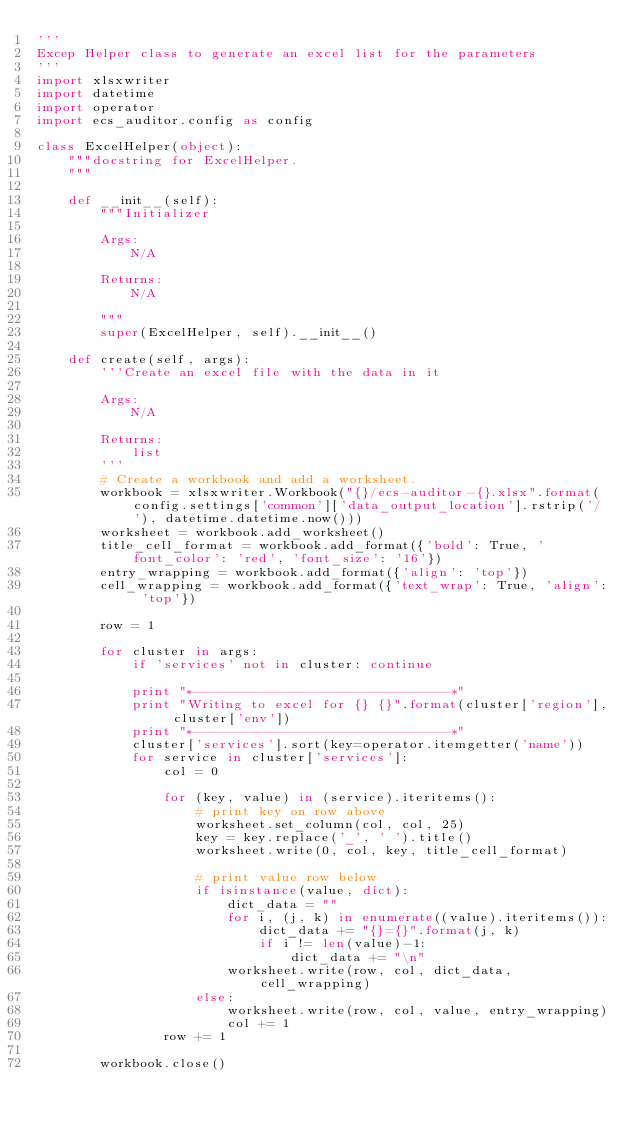Convert code to text. <code><loc_0><loc_0><loc_500><loc_500><_Python_>'''
Excep Helper class to generate an excel list for the parameters
'''
import xlsxwriter
import datetime
import operator
import ecs_auditor.config as config

class ExcelHelper(object):
    """docstring for ExcelHelper.
    """

    def __init__(self):
        """Initializer

        Args:
            N/A

        Returns:
            N/A

        """
        super(ExcelHelper, self).__init__()

    def create(self, args):
        '''Create an excel file with the data in it

        Args:
            N/A

        Returns:
            list
        '''
        # Create a workbook and add a worksheet.
        workbook = xlsxwriter.Workbook("{}/ecs-auditor-{}.xlsx".format(config.settings['common']['data_output_location'].rstrip('/'), datetime.datetime.now()))
        worksheet = workbook.add_worksheet()
        title_cell_format = workbook.add_format({'bold': True, 'font_color': 'red', 'font_size': '16'})
        entry_wrapping = workbook.add_format({'align': 'top'})
        cell_wrapping = workbook.add_format({'text_wrap': True, 'align': 'top'})

        row = 1

        for cluster in args:
            if 'services' not in cluster: continue

            print "*--------------------------------*"
            print "Writing to excel for {} {}".format(cluster['region'], cluster['env'])
            print "*--------------------------------*"
            cluster['services'].sort(key=operator.itemgetter('name'))
            for service in cluster['services']:
                col = 0

                for (key, value) in (service).iteritems():
                    # print key on row above
                    worksheet.set_column(col, col, 25)
                    key = key.replace('_', ' ').title()
                    worksheet.write(0, col, key, title_cell_format)

                    # print value row below
                    if isinstance(value, dict):
                        dict_data = ""
                        for i, (j, k) in enumerate((value).iteritems()):
                            dict_data += "{}={}".format(j, k)
                            if i != len(value)-1:
                                dict_data += "\n"
                        worksheet.write(row, col, dict_data, cell_wrapping)
                    else:
                        worksheet.write(row, col, value, entry_wrapping)
                        col += 1
                row += 1

        workbook.close()
</code> 